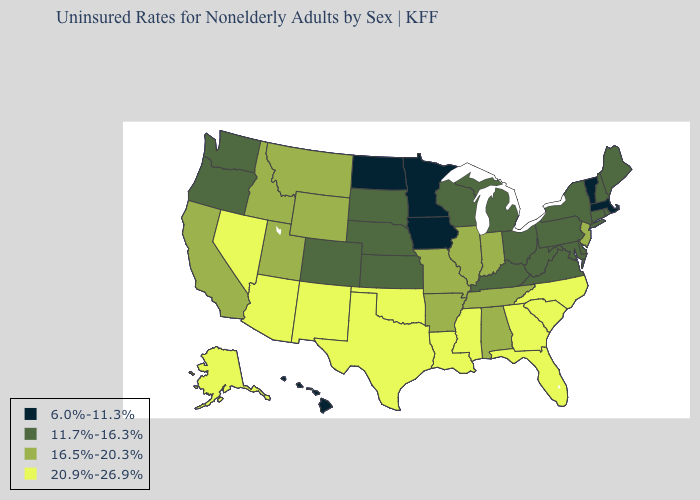What is the value of Illinois?
Quick response, please. 16.5%-20.3%. Name the states that have a value in the range 6.0%-11.3%?
Keep it brief. Hawaii, Iowa, Massachusetts, Minnesota, North Dakota, Vermont. Does the first symbol in the legend represent the smallest category?
Be succinct. Yes. Name the states that have a value in the range 16.5%-20.3%?
Answer briefly. Alabama, Arkansas, California, Idaho, Illinois, Indiana, Missouri, Montana, New Jersey, Tennessee, Utah, Wyoming. What is the lowest value in the USA?
Be succinct. 6.0%-11.3%. Does the map have missing data?
Write a very short answer. No. How many symbols are there in the legend?
Quick response, please. 4. Does the map have missing data?
Answer briefly. No. Name the states that have a value in the range 6.0%-11.3%?
Quick response, please. Hawaii, Iowa, Massachusetts, Minnesota, North Dakota, Vermont. Name the states that have a value in the range 20.9%-26.9%?
Write a very short answer. Alaska, Arizona, Florida, Georgia, Louisiana, Mississippi, Nevada, New Mexico, North Carolina, Oklahoma, South Carolina, Texas. Name the states that have a value in the range 16.5%-20.3%?
Write a very short answer. Alabama, Arkansas, California, Idaho, Illinois, Indiana, Missouri, Montana, New Jersey, Tennessee, Utah, Wyoming. Name the states that have a value in the range 16.5%-20.3%?
Short answer required. Alabama, Arkansas, California, Idaho, Illinois, Indiana, Missouri, Montana, New Jersey, Tennessee, Utah, Wyoming. Name the states that have a value in the range 16.5%-20.3%?
Short answer required. Alabama, Arkansas, California, Idaho, Illinois, Indiana, Missouri, Montana, New Jersey, Tennessee, Utah, Wyoming. Name the states that have a value in the range 11.7%-16.3%?
Keep it brief. Colorado, Connecticut, Delaware, Kansas, Kentucky, Maine, Maryland, Michigan, Nebraska, New Hampshire, New York, Ohio, Oregon, Pennsylvania, Rhode Island, South Dakota, Virginia, Washington, West Virginia, Wisconsin. Name the states that have a value in the range 11.7%-16.3%?
Give a very brief answer. Colorado, Connecticut, Delaware, Kansas, Kentucky, Maine, Maryland, Michigan, Nebraska, New Hampshire, New York, Ohio, Oregon, Pennsylvania, Rhode Island, South Dakota, Virginia, Washington, West Virginia, Wisconsin. 